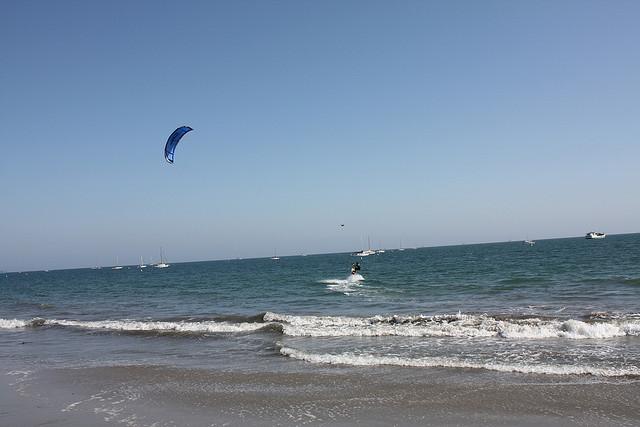Was the camera held level?
Write a very short answer. No. Is it a cloudy day?
Concise answer only. No. What is the object flying over the sea?
Short answer required. Kite. Will the person get hurt if they fall?
Write a very short answer. Yes. Does the Ocean touch the sky?
Keep it brief. No. How many boats can you make out in the water?
Concise answer only. 4. Is the person windsurfing?
Quick response, please. Yes. 